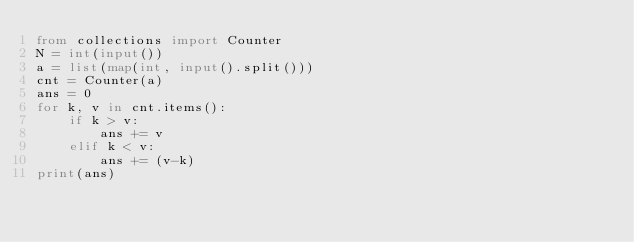Convert code to text. <code><loc_0><loc_0><loc_500><loc_500><_Python_>from collections import Counter
N = int(input())
a = list(map(int, input().split()))
cnt = Counter(a)
ans = 0
for k, v in cnt.items():
    if k > v:
        ans += v
    elif k < v:
        ans += (v-k)
print(ans)
</code> 